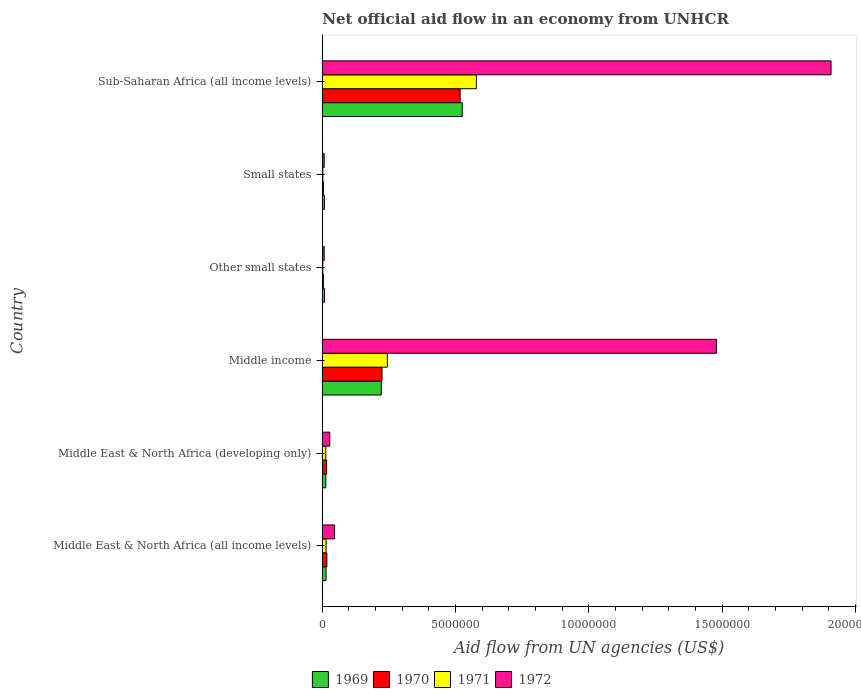How many groups of bars are there?
Provide a succinct answer. 6. Are the number of bars on each tick of the Y-axis equal?
Keep it short and to the point. Yes. How many bars are there on the 1st tick from the top?
Make the answer very short. 4. How many bars are there on the 4th tick from the bottom?
Your answer should be very brief. 4. What is the label of the 3rd group of bars from the top?
Offer a very short reply. Other small states. In how many cases, is the number of bars for a given country not equal to the number of legend labels?
Keep it short and to the point. 0. What is the net official aid flow in 1971 in Middle income?
Provide a succinct answer. 2.44e+06. Across all countries, what is the maximum net official aid flow in 1972?
Give a very brief answer. 1.91e+07. In which country was the net official aid flow in 1972 maximum?
Offer a very short reply. Sub-Saharan Africa (all income levels). In which country was the net official aid flow in 1972 minimum?
Make the answer very short. Other small states. What is the total net official aid flow in 1971 in the graph?
Your response must be concise. 8.53e+06. What is the difference between the net official aid flow in 1970 in Middle income and that in Sub-Saharan Africa (all income levels)?
Keep it short and to the point. -2.93e+06. What is the average net official aid flow in 1972 per country?
Ensure brevity in your answer.  5.79e+06. What is the ratio of the net official aid flow in 1972 in Small states to that in Sub-Saharan Africa (all income levels)?
Offer a terse response. 0. Is the net official aid flow in 1972 in Middle income less than that in Sub-Saharan Africa (all income levels)?
Ensure brevity in your answer.  Yes. What is the difference between the highest and the second highest net official aid flow in 1972?
Provide a short and direct response. 4.30e+06. What is the difference between the highest and the lowest net official aid flow in 1972?
Ensure brevity in your answer.  1.90e+07. In how many countries, is the net official aid flow in 1972 greater than the average net official aid flow in 1972 taken over all countries?
Your answer should be compact. 2. Is the sum of the net official aid flow in 1971 in Middle income and Small states greater than the maximum net official aid flow in 1969 across all countries?
Your response must be concise. No. Is it the case that in every country, the sum of the net official aid flow in 1971 and net official aid flow in 1970 is greater than the sum of net official aid flow in 1972 and net official aid flow in 1969?
Ensure brevity in your answer.  No. What does the 3rd bar from the top in Middle income represents?
Ensure brevity in your answer.  1970. What does the 2nd bar from the bottom in Other small states represents?
Provide a succinct answer. 1970. Are all the bars in the graph horizontal?
Offer a terse response. Yes. How many countries are there in the graph?
Make the answer very short. 6. What is the difference between two consecutive major ticks on the X-axis?
Keep it short and to the point. 5.00e+06. Where does the legend appear in the graph?
Your answer should be compact. Bottom center. How are the legend labels stacked?
Make the answer very short. Horizontal. What is the title of the graph?
Offer a terse response. Net official aid flow in an economy from UNHCR. Does "1996" appear as one of the legend labels in the graph?
Provide a succinct answer. No. What is the label or title of the X-axis?
Your answer should be very brief. Aid flow from UN agencies (US$). What is the Aid flow from UN agencies (US$) in 1970 in Middle East & North Africa (all income levels)?
Keep it short and to the point. 1.70e+05. What is the Aid flow from UN agencies (US$) of 1972 in Middle East & North Africa (all income levels)?
Provide a succinct answer. 4.60e+05. What is the Aid flow from UN agencies (US$) of 1970 in Middle East & North Africa (developing only)?
Your response must be concise. 1.60e+05. What is the Aid flow from UN agencies (US$) in 1971 in Middle East & North Africa (developing only)?
Your answer should be very brief. 1.30e+05. What is the Aid flow from UN agencies (US$) of 1969 in Middle income?
Give a very brief answer. 2.21e+06. What is the Aid flow from UN agencies (US$) in 1970 in Middle income?
Your response must be concise. 2.24e+06. What is the Aid flow from UN agencies (US$) of 1971 in Middle income?
Offer a very short reply. 2.44e+06. What is the Aid flow from UN agencies (US$) in 1972 in Middle income?
Your answer should be very brief. 1.48e+07. What is the Aid flow from UN agencies (US$) in 1969 in Other small states?
Provide a short and direct response. 8.00e+04. What is the Aid flow from UN agencies (US$) of 1970 in Other small states?
Offer a very short reply. 4.00e+04. What is the Aid flow from UN agencies (US$) in 1971 in Other small states?
Offer a terse response. 2.00e+04. What is the Aid flow from UN agencies (US$) in 1969 in Small states?
Give a very brief answer. 8.00e+04. What is the Aid flow from UN agencies (US$) of 1971 in Small states?
Offer a terse response. 2.00e+04. What is the Aid flow from UN agencies (US$) of 1969 in Sub-Saharan Africa (all income levels)?
Your answer should be compact. 5.25e+06. What is the Aid flow from UN agencies (US$) in 1970 in Sub-Saharan Africa (all income levels)?
Give a very brief answer. 5.17e+06. What is the Aid flow from UN agencies (US$) of 1971 in Sub-Saharan Africa (all income levels)?
Keep it short and to the point. 5.78e+06. What is the Aid flow from UN agencies (US$) in 1972 in Sub-Saharan Africa (all income levels)?
Make the answer very short. 1.91e+07. Across all countries, what is the maximum Aid flow from UN agencies (US$) of 1969?
Make the answer very short. 5.25e+06. Across all countries, what is the maximum Aid flow from UN agencies (US$) of 1970?
Your answer should be very brief. 5.17e+06. Across all countries, what is the maximum Aid flow from UN agencies (US$) of 1971?
Provide a short and direct response. 5.78e+06. Across all countries, what is the maximum Aid flow from UN agencies (US$) of 1972?
Your answer should be compact. 1.91e+07. Across all countries, what is the minimum Aid flow from UN agencies (US$) in 1971?
Your answer should be very brief. 2.00e+04. What is the total Aid flow from UN agencies (US$) in 1969 in the graph?
Your response must be concise. 7.89e+06. What is the total Aid flow from UN agencies (US$) of 1970 in the graph?
Provide a short and direct response. 7.82e+06. What is the total Aid flow from UN agencies (US$) in 1971 in the graph?
Offer a very short reply. 8.53e+06. What is the total Aid flow from UN agencies (US$) of 1972 in the graph?
Your response must be concise. 3.48e+07. What is the difference between the Aid flow from UN agencies (US$) of 1971 in Middle East & North Africa (all income levels) and that in Middle East & North Africa (developing only)?
Provide a short and direct response. 10000. What is the difference between the Aid flow from UN agencies (US$) of 1972 in Middle East & North Africa (all income levels) and that in Middle East & North Africa (developing only)?
Offer a terse response. 1.80e+05. What is the difference between the Aid flow from UN agencies (US$) in 1969 in Middle East & North Africa (all income levels) and that in Middle income?
Keep it short and to the point. -2.07e+06. What is the difference between the Aid flow from UN agencies (US$) in 1970 in Middle East & North Africa (all income levels) and that in Middle income?
Keep it short and to the point. -2.07e+06. What is the difference between the Aid flow from UN agencies (US$) in 1971 in Middle East & North Africa (all income levels) and that in Middle income?
Your answer should be compact. -2.30e+06. What is the difference between the Aid flow from UN agencies (US$) of 1972 in Middle East & North Africa (all income levels) and that in Middle income?
Make the answer very short. -1.43e+07. What is the difference between the Aid flow from UN agencies (US$) of 1969 in Middle East & North Africa (all income levels) and that in Small states?
Make the answer very short. 6.00e+04. What is the difference between the Aid flow from UN agencies (US$) of 1970 in Middle East & North Africa (all income levels) and that in Small states?
Make the answer very short. 1.30e+05. What is the difference between the Aid flow from UN agencies (US$) in 1971 in Middle East & North Africa (all income levels) and that in Small states?
Your response must be concise. 1.20e+05. What is the difference between the Aid flow from UN agencies (US$) in 1972 in Middle East & North Africa (all income levels) and that in Small states?
Provide a succinct answer. 3.90e+05. What is the difference between the Aid flow from UN agencies (US$) of 1969 in Middle East & North Africa (all income levels) and that in Sub-Saharan Africa (all income levels)?
Your response must be concise. -5.11e+06. What is the difference between the Aid flow from UN agencies (US$) in 1970 in Middle East & North Africa (all income levels) and that in Sub-Saharan Africa (all income levels)?
Your answer should be very brief. -5.00e+06. What is the difference between the Aid flow from UN agencies (US$) of 1971 in Middle East & North Africa (all income levels) and that in Sub-Saharan Africa (all income levels)?
Offer a terse response. -5.64e+06. What is the difference between the Aid flow from UN agencies (US$) in 1972 in Middle East & North Africa (all income levels) and that in Sub-Saharan Africa (all income levels)?
Keep it short and to the point. -1.86e+07. What is the difference between the Aid flow from UN agencies (US$) in 1969 in Middle East & North Africa (developing only) and that in Middle income?
Provide a short and direct response. -2.08e+06. What is the difference between the Aid flow from UN agencies (US$) in 1970 in Middle East & North Africa (developing only) and that in Middle income?
Ensure brevity in your answer.  -2.08e+06. What is the difference between the Aid flow from UN agencies (US$) of 1971 in Middle East & North Africa (developing only) and that in Middle income?
Make the answer very short. -2.31e+06. What is the difference between the Aid flow from UN agencies (US$) of 1972 in Middle East & North Africa (developing only) and that in Middle income?
Ensure brevity in your answer.  -1.45e+07. What is the difference between the Aid flow from UN agencies (US$) in 1972 in Middle East & North Africa (developing only) and that in Other small states?
Your response must be concise. 2.10e+05. What is the difference between the Aid flow from UN agencies (US$) of 1969 in Middle East & North Africa (developing only) and that in Small states?
Offer a terse response. 5.00e+04. What is the difference between the Aid flow from UN agencies (US$) of 1971 in Middle East & North Africa (developing only) and that in Small states?
Offer a terse response. 1.10e+05. What is the difference between the Aid flow from UN agencies (US$) of 1969 in Middle East & North Africa (developing only) and that in Sub-Saharan Africa (all income levels)?
Keep it short and to the point. -5.12e+06. What is the difference between the Aid flow from UN agencies (US$) in 1970 in Middle East & North Africa (developing only) and that in Sub-Saharan Africa (all income levels)?
Give a very brief answer. -5.01e+06. What is the difference between the Aid flow from UN agencies (US$) of 1971 in Middle East & North Africa (developing only) and that in Sub-Saharan Africa (all income levels)?
Offer a terse response. -5.65e+06. What is the difference between the Aid flow from UN agencies (US$) in 1972 in Middle East & North Africa (developing only) and that in Sub-Saharan Africa (all income levels)?
Keep it short and to the point. -1.88e+07. What is the difference between the Aid flow from UN agencies (US$) in 1969 in Middle income and that in Other small states?
Keep it short and to the point. 2.13e+06. What is the difference between the Aid flow from UN agencies (US$) in 1970 in Middle income and that in Other small states?
Offer a very short reply. 2.20e+06. What is the difference between the Aid flow from UN agencies (US$) of 1971 in Middle income and that in Other small states?
Offer a terse response. 2.42e+06. What is the difference between the Aid flow from UN agencies (US$) of 1972 in Middle income and that in Other small states?
Provide a short and direct response. 1.47e+07. What is the difference between the Aid flow from UN agencies (US$) of 1969 in Middle income and that in Small states?
Provide a short and direct response. 2.13e+06. What is the difference between the Aid flow from UN agencies (US$) of 1970 in Middle income and that in Small states?
Provide a succinct answer. 2.20e+06. What is the difference between the Aid flow from UN agencies (US$) in 1971 in Middle income and that in Small states?
Ensure brevity in your answer.  2.42e+06. What is the difference between the Aid flow from UN agencies (US$) of 1972 in Middle income and that in Small states?
Your response must be concise. 1.47e+07. What is the difference between the Aid flow from UN agencies (US$) of 1969 in Middle income and that in Sub-Saharan Africa (all income levels)?
Make the answer very short. -3.04e+06. What is the difference between the Aid flow from UN agencies (US$) in 1970 in Middle income and that in Sub-Saharan Africa (all income levels)?
Ensure brevity in your answer.  -2.93e+06. What is the difference between the Aid flow from UN agencies (US$) of 1971 in Middle income and that in Sub-Saharan Africa (all income levels)?
Provide a succinct answer. -3.34e+06. What is the difference between the Aid flow from UN agencies (US$) of 1972 in Middle income and that in Sub-Saharan Africa (all income levels)?
Provide a succinct answer. -4.30e+06. What is the difference between the Aid flow from UN agencies (US$) of 1969 in Other small states and that in Small states?
Your response must be concise. 0. What is the difference between the Aid flow from UN agencies (US$) in 1971 in Other small states and that in Small states?
Provide a succinct answer. 0. What is the difference between the Aid flow from UN agencies (US$) of 1969 in Other small states and that in Sub-Saharan Africa (all income levels)?
Give a very brief answer. -5.17e+06. What is the difference between the Aid flow from UN agencies (US$) in 1970 in Other small states and that in Sub-Saharan Africa (all income levels)?
Offer a very short reply. -5.13e+06. What is the difference between the Aid flow from UN agencies (US$) in 1971 in Other small states and that in Sub-Saharan Africa (all income levels)?
Provide a succinct answer. -5.76e+06. What is the difference between the Aid flow from UN agencies (US$) of 1972 in Other small states and that in Sub-Saharan Africa (all income levels)?
Keep it short and to the point. -1.90e+07. What is the difference between the Aid flow from UN agencies (US$) in 1969 in Small states and that in Sub-Saharan Africa (all income levels)?
Ensure brevity in your answer.  -5.17e+06. What is the difference between the Aid flow from UN agencies (US$) of 1970 in Small states and that in Sub-Saharan Africa (all income levels)?
Give a very brief answer. -5.13e+06. What is the difference between the Aid flow from UN agencies (US$) of 1971 in Small states and that in Sub-Saharan Africa (all income levels)?
Give a very brief answer. -5.76e+06. What is the difference between the Aid flow from UN agencies (US$) of 1972 in Small states and that in Sub-Saharan Africa (all income levels)?
Offer a terse response. -1.90e+07. What is the difference between the Aid flow from UN agencies (US$) of 1969 in Middle East & North Africa (all income levels) and the Aid flow from UN agencies (US$) of 1971 in Middle East & North Africa (developing only)?
Offer a very short reply. 10000. What is the difference between the Aid flow from UN agencies (US$) in 1969 in Middle East & North Africa (all income levels) and the Aid flow from UN agencies (US$) in 1972 in Middle East & North Africa (developing only)?
Your response must be concise. -1.40e+05. What is the difference between the Aid flow from UN agencies (US$) in 1971 in Middle East & North Africa (all income levels) and the Aid flow from UN agencies (US$) in 1972 in Middle East & North Africa (developing only)?
Ensure brevity in your answer.  -1.40e+05. What is the difference between the Aid flow from UN agencies (US$) in 1969 in Middle East & North Africa (all income levels) and the Aid flow from UN agencies (US$) in 1970 in Middle income?
Keep it short and to the point. -2.10e+06. What is the difference between the Aid flow from UN agencies (US$) in 1969 in Middle East & North Africa (all income levels) and the Aid flow from UN agencies (US$) in 1971 in Middle income?
Your response must be concise. -2.30e+06. What is the difference between the Aid flow from UN agencies (US$) in 1969 in Middle East & North Africa (all income levels) and the Aid flow from UN agencies (US$) in 1972 in Middle income?
Offer a terse response. -1.46e+07. What is the difference between the Aid flow from UN agencies (US$) of 1970 in Middle East & North Africa (all income levels) and the Aid flow from UN agencies (US$) of 1971 in Middle income?
Your answer should be very brief. -2.27e+06. What is the difference between the Aid flow from UN agencies (US$) in 1970 in Middle East & North Africa (all income levels) and the Aid flow from UN agencies (US$) in 1972 in Middle income?
Offer a very short reply. -1.46e+07. What is the difference between the Aid flow from UN agencies (US$) of 1971 in Middle East & North Africa (all income levels) and the Aid flow from UN agencies (US$) of 1972 in Middle income?
Your answer should be very brief. -1.46e+07. What is the difference between the Aid flow from UN agencies (US$) in 1969 in Middle East & North Africa (all income levels) and the Aid flow from UN agencies (US$) in 1970 in Other small states?
Provide a short and direct response. 1.00e+05. What is the difference between the Aid flow from UN agencies (US$) in 1970 in Middle East & North Africa (all income levels) and the Aid flow from UN agencies (US$) in 1971 in Other small states?
Offer a terse response. 1.50e+05. What is the difference between the Aid flow from UN agencies (US$) in 1971 in Middle East & North Africa (all income levels) and the Aid flow from UN agencies (US$) in 1972 in Other small states?
Ensure brevity in your answer.  7.00e+04. What is the difference between the Aid flow from UN agencies (US$) in 1969 in Middle East & North Africa (all income levels) and the Aid flow from UN agencies (US$) in 1972 in Small states?
Your answer should be compact. 7.00e+04. What is the difference between the Aid flow from UN agencies (US$) in 1970 in Middle East & North Africa (all income levels) and the Aid flow from UN agencies (US$) in 1971 in Small states?
Your answer should be very brief. 1.50e+05. What is the difference between the Aid flow from UN agencies (US$) of 1970 in Middle East & North Africa (all income levels) and the Aid flow from UN agencies (US$) of 1972 in Small states?
Offer a very short reply. 1.00e+05. What is the difference between the Aid flow from UN agencies (US$) in 1971 in Middle East & North Africa (all income levels) and the Aid flow from UN agencies (US$) in 1972 in Small states?
Offer a very short reply. 7.00e+04. What is the difference between the Aid flow from UN agencies (US$) of 1969 in Middle East & North Africa (all income levels) and the Aid flow from UN agencies (US$) of 1970 in Sub-Saharan Africa (all income levels)?
Your answer should be very brief. -5.03e+06. What is the difference between the Aid flow from UN agencies (US$) in 1969 in Middle East & North Africa (all income levels) and the Aid flow from UN agencies (US$) in 1971 in Sub-Saharan Africa (all income levels)?
Give a very brief answer. -5.64e+06. What is the difference between the Aid flow from UN agencies (US$) in 1969 in Middle East & North Africa (all income levels) and the Aid flow from UN agencies (US$) in 1972 in Sub-Saharan Africa (all income levels)?
Give a very brief answer. -1.90e+07. What is the difference between the Aid flow from UN agencies (US$) in 1970 in Middle East & North Africa (all income levels) and the Aid flow from UN agencies (US$) in 1971 in Sub-Saharan Africa (all income levels)?
Keep it short and to the point. -5.61e+06. What is the difference between the Aid flow from UN agencies (US$) in 1970 in Middle East & North Africa (all income levels) and the Aid flow from UN agencies (US$) in 1972 in Sub-Saharan Africa (all income levels)?
Give a very brief answer. -1.89e+07. What is the difference between the Aid flow from UN agencies (US$) of 1971 in Middle East & North Africa (all income levels) and the Aid flow from UN agencies (US$) of 1972 in Sub-Saharan Africa (all income levels)?
Your answer should be compact. -1.90e+07. What is the difference between the Aid flow from UN agencies (US$) in 1969 in Middle East & North Africa (developing only) and the Aid flow from UN agencies (US$) in 1970 in Middle income?
Your response must be concise. -2.11e+06. What is the difference between the Aid flow from UN agencies (US$) in 1969 in Middle East & North Africa (developing only) and the Aid flow from UN agencies (US$) in 1971 in Middle income?
Your answer should be compact. -2.31e+06. What is the difference between the Aid flow from UN agencies (US$) of 1969 in Middle East & North Africa (developing only) and the Aid flow from UN agencies (US$) of 1972 in Middle income?
Offer a very short reply. -1.47e+07. What is the difference between the Aid flow from UN agencies (US$) in 1970 in Middle East & North Africa (developing only) and the Aid flow from UN agencies (US$) in 1971 in Middle income?
Provide a succinct answer. -2.28e+06. What is the difference between the Aid flow from UN agencies (US$) in 1970 in Middle East & North Africa (developing only) and the Aid flow from UN agencies (US$) in 1972 in Middle income?
Offer a very short reply. -1.46e+07. What is the difference between the Aid flow from UN agencies (US$) in 1971 in Middle East & North Africa (developing only) and the Aid flow from UN agencies (US$) in 1972 in Middle income?
Keep it short and to the point. -1.47e+07. What is the difference between the Aid flow from UN agencies (US$) in 1969 in Middle East & North Africa (developing only) and the Aid flow from UN agencies (US$) in 1970 in Other small states?
Your response must be concise. 9.00e+04. What is the difference between the Aid flow from UN agencies (US$) in 1969 in Middle East & North Africa (developing only) and the Aid flow from UN agencies (US$) in 1971 in Other small states?
Offer a terse response. 1.10e+05. What is the difference between the Aid flow from UN agencies (US$) of 1969 in Middle East & North Africa (developing only) and the Aid flow from UN agencies (US$) of 1972 in Other small states?
Provide a short and direct response. 6.00e+04. What is the difference between the Aid flow from UN agencies (US$) of 1970 in Middle East & North Africa (developing only) and the Aid flow from UN agencies (US$) of 1971 in Other small states?
Provide a succinct answer. 1.40e+05. What is the difference between the Aid flow from UN agencies (US$) of 1970 in Middle East & North Africa (developing only) and the Aid flow from UN agencies (US$) of 1972 in Other small states?
Ensure brevity in your answer.  9.00e+04. What is the difference between the Aid flow from UN agencies (US$) in 1969 in Middle East & North Africa (developing only) and the Aid flow from UN agencies (US$) in 1970 in Small states?
Give a very brief answer. 9.00e+04. What is the difference between the Aid flow from UN agencies (US$) of 1969 in Middle East & North Africa (developing only) and the Aid flow from UN agencies (US$) of 1971 in Small states?
Provide a succinct answer. 1.10e+05. What is the difference between the Aid flow from UN agencies (US$) in 1970 in Middle East & North Africa (developing only) and the Aid flow from UN agencies (US$) in 1972 in Small states?
Your answer should be compact. 9.00e+04. What is the difference between the Aid flow from UN agencies (US$) of 1969 in Middle East & North Africa (developing only) and the Aid flow from UN agencies (US$) of 1970 in Sub-Saharan Africa (all income levels)?
Offer a very short reply. -5.04e+06. What is the difference between the Aid flow from UN agencies (US$) of 1969 in Middle East & North Africa (developing only) and the Aid flow from UN agencies (US$) of 1971 in Sub-Saharan Africa (all income levels)?
Your response must be concise. -5.65e+06. What is the difference between the Aid flow from UN agencies (US$) in 1969 in Middle East & North Africa (developing only) and the Aid flow from UN agencies (US$) in 1972 in Sub-Saharan Africa (all income levels)?
Make the answer very short. -1.90e+07. What is the difference between the Aid flow from UN agencies (US$) of 1970 in Middle East & North Africa (developing only) and the Aid flow from UN agencies (US$) of 1971 in Sub-Saharan Africa (all income levels)?
Provide a short and direct response. -5.62e+06. What is the difference between the Aid flow from UN agencies (US$) in 1970 in Middle East & North Africa (developing only) and the Aid flow from UN agencies (US$) in 1972 in Sub-Saharan Africa (all income levels)?
Make the answer very short. -1.89e+07. What is the difference between the Aid flow from UN agencies (US$) of 1971 in Middle East & North Africa (developing only) and the Aid flow from UN agencies (US$) of 1972 in Sub-Saharan Africa (all income levels)?
Provide a succinct answer. -1.90e+07. What is the difference between the Aid flow from UN agencies (US$) in 1969 in Middle income and the Aid flow from UN agencies (US$) in 1970 in Other small states?
Give a very brief answer. 2.17e+06. What is the difference between the Aid flow from UN agencies (US$) in 1969 in Middle income and the Aid flow from UN agencies (US$) in 1971 in Other small states?
Ensure brevity in your answer.  2.19e+06. What is the difference between the Aid flow from UN agencies (US$) of 1969 in Middle income and the Aid flow from UN agencies (US$) of 1972 in Other small states?
Ensure brevity in your answer.  2.14e+06. What is the difference between the Aid flow from UN agencies (US$) in 1970 in Middle income and the Aid flow from UN agencies (US$) in 1971 in Other small states?
Your answer should be very brief. 2.22e+06. What is the difference between the Aid flow from UN agencies (US$) in 1970 in Middle income and the Aid flow from UN agencies (US$) in 1972 in Other small states?
Make the answer very short. 2.17e+06. What is the difference between the Aid flow from UN agencies (US$) in 1971 in Middle income and the Aid flow from UN agencies (US$) in 1972 in Other small states?
Make the answer very short. 2.37e+06. What is the difference between the Aid flow from UN agencies (US$) in 1969 in Middle income and the Aid flow from UN agencies (US$) in 1970 in Small states?
Offer a terse response. 2.17e+06. What is the difference between the Aid flow from UN agencies (US$) in 1969 in Middle income and the Aid flow from UN agencies (US$) in 1971 in Small states?
Ensure brevity in your answer.  2.19e+06. What is the difference between the Aid flow from UN agencies (US$) in 1969 in Middle income and the Aid flow from UN agencies (US$) in 1972 in Small states?
Provide a succinct answer. 2.14e+06. What is the difference between the Aid flow from UN agencies (US$) of 1970 in Middle income and the Aid flow from UN agencies (US$) of 1971 in Small states?
Make the answer very short. 2.22e+06. What is the difference between the Aid flow from UN agencies (US$) of 1970 in Middle income and the Aid flow from UN agencies (US$) of 1972 in Small states?
Provide a succinct answer. 2.17e+06. What is the difference between the Aid flow from UN agencies (US$) in 1971 in Middle income and the Aid flow from UN agencies (US$) in 1972 in Small states?
Give a very brief answer. 2.37e+06. What is the difference between the Aid flow from UN agencies (US$) in 1969 in Middle income and the Aid flow from UN agencies (US$) in 1970 in Sub-Saharan Africa (all income levels)?
Your answer should be very brief. -2.96e+06. What is the difference between the Aid flow from UN agencies (US$) of 1969 in Middle income and the Aid flow from UN agencies (US$) of 1971 in Sub-Saharan Africa (all income levels)?
Make the answer very short. -3.57e+06. What is the difference between the Aid flow from UN agencies (US$) of 1969 in Middle income and the Aid flow from UN agencies (US$) of 1972 in Sub-Saharan Africa (all income levels)?
Your answer should be compact. -1.69e+07. What is the difference between the Aid flow from UN agencies (US$) of 1970 in Middle income and the Aid flow from UN agencies (US$) of 1971 in Sub-Saharan Africa (all income levels)?
Your answer should be compact. -3.54e+06. What is the difference between the Aid flow from UN agencies (US$) of 1970 in Middle income and the Aid flow from UN agencies (US$) of 1972 in Sub-Saharan Africa (all income levels)?
Provide a short and direct response. -1.68e+07. What is the difference between the Aid flow from UN agencies (US$) of 1971 in Middle income and the Aid flow from UN agencies (US$) of 1972 in Sub-Saharan Africa (all income levels)?
Give a very brief answer. -1.66e+07. What is the difference between the Aid flow from UN agencies (US$) of 1969 in Other small states and the Aid flow from UN agencies (US$) of 1970 in Small states?
Offer a terse response. 4.00e+04. What is the difference between the Aid flow from UN agencies (US$) of 1969 in Other small states and the Aid flow from UN agencies (US$) of 1971 in Small states?
Give a very brief answer. 6.00e+04. What is the difference between the Aid flow from UN agencies (US$) of 1969 in Other small states and the Aid flow from UN agencies (US$) of 1972 in Small states?
Your answer should be very brief. 10000. What is the difference between the Aid flow from UN agencies (US$) of 1970 in Other small states and the Aid flow from UN agencies (US$) of 1972 in Small states?
Offer a terse response. -3.00e+04. What is the difference between the Aid flow from UN agencies (US$) of 1971 in Other small states and the Aid flow from UN agencies (US$) of 1972 in Small states?
Provide a succinct answer. -5.00e+04. What is the difference between the Aid flow from UN agencies (US$) in 1969 in Other small states and the Aid flow from UN agencies (US$) in 1970 in Sub-Saharan Africa (all income levels)?
Offer a very short reply. -5.09e+06. What is the difference between the Aid flow from UN agencies (US$) of 1969 in Other small states and the Aid flow from UN agencies (US$) of 1971 in Sub-Saharan Africa (all income levels)?
Make the answer very short. -5.70e+06. What is the difference between the Aid flow from UN agencies (US$) of 1969 in Other small states and the Aid flow from UN agencies (US$) of 1972 in Sub-Saharan Africa (all income levels)?
Keep it short and to the point. -1.90e+07. What is the difference between the Aid flow from UN agencies (US$) in 1970 in Other small states and the Aid flow from UN agencies (US$) in 1971 in Sub-Saharan Africa (all income levels)?
Offer a very short reply. -5.74e+06. What is the difference between the Aid flow from UN agencies (US$) of 1970 in Other small states and the Aid flow from UN agencies (US$) of 1972 in Sub-Saharan Africa (all income levels)?
Your response must be concise. -1.90e+07. What is the difference between the Aid flow from UN agencies (US$) in 1971 in Other small states and the Aid flow from UN agencies (US$) in 1972 in Sub-Saharan Africa (all income levels)?
Your answer should be very brief. -1.91e+07. What is the difference between the Aid flow from UN agencies (US$) in 1969 in Small states and the Aid flow from UN agencies (US$) in 1970 in Sub-Saharan Africa (all income levels)?
Ensure brevity in your answer.  -5.09e+06. What is the difference between the Aid flow from UN agencies (US$) of 1969 in Small states and the Aid flow from UN agencies (US$) of 1971 in Sub-Saharan Africa (all income levels)?
Provide a short and direct response. -5.70e+06. What is the difference between the Aid flow from UN agencies (US$) of 1969 in Small states and the Aid flow from UN agencies (US$) of 1972 in Sub-Saharan Africa (all income levels)?
Make the answer very short. -1.90e+07. What is the difference between the Aid flow from UN agencies (US$) of 1970 in Small states and the Aid flow from UN agencies (US$) of 1971 in Sub-Saharan Africa (all income levels)?
Give a very brief answer. -5.74e+06. What is the difference between the Aid flow from UN agencies (US$) in 1970 in Small states and the Aid flow from UN agencies (US$) in 1972 in Sub-Saharan Africa (all income levels)?
Keep it short and to the point. -1.90e+07. What is the difference between the Aid flow from UN agencies (US$) in 1971 in Small states and the Aid flow from UN agencies (US$) in 1972 in Sub-Saharan Africa (all income levels)?
Make the answer very short. -1.91e+07. What is the average Aid flow from UN agencies (US$) in 1969 per country?
Offer a terse response. 1.32e+06. What is the average Aid flow from UN agencies (US$) in 1970 per country?
Keep it short and to the point. 1.30e+06. What is the average Aid flow from UN agencies (US$) of 1971 per country?
Your answer should be compact. 1.42e+06. What is the average Aid flow from UN agencies (US$) of 1972 per country?
Ensure brevity in your answer.  5.79e+06. What is the difference between the Aid flow from UN agencies (US$) in 1969 and Aid flow from UN agencies (US$) in 1970 in Middle East & North Africa (all income levels)?
Your answer should be very brief. -3.00e+04. What is the difference between the Aid flow from UN agencies (US$) of 1969 and Aid flow from UN agencies (US$) of 1972 in Middle East & North Africa (all income levels)?
Provide a short and direct response. -3.20e+05. What is the difference between the Aid flow from UN agencies (US$) of 1970 and Aid flow from UN agencies (US$) of 1971 in Middle East & North Africa (all income levels)?
Offer a terse response. 3.00e+04. What is the difference between the Aid flow from UN agencies (US$) of 1971 and Aid flow from UN agencies (US$) of 1972 in Middle East & North Africa (all income levels)?
Offer a terse response. -3.20e+05. What is the difference between the Aid flow from UN agencies (US$) of 1969 and Aid flow from UN agencies (US$) of 1970 in Middle East & North Africa (developing only)?
Offer a very short reply. -3.00e+04. What is the difference between the Aid flow from UN agencies (US$) of 1969 and Aid flow from UN agencies (US$) of 1971 in Middle East & North Africa (developing only)?
Offer a very short reply. 0. What is the difference between the Aid flow from UN agencies (US$) of 1969 and Aid flow from UN agencies (US$) of 1972 in Middle East & North Africa (developing only)?
Give a very brief answer. -1.50e+05. What is the difference between the Aid flow from UN agencies (US$) of 1970 and Aid flow from UN agencies (US$) of 1972 in Middle East & North Africa (developing only)?
Make the answer very short. -1.20e+05. What is the difference between the Aid flow from UN agencies (US$) of 1971 and Aid flow from UN agencies (US$) of 1972 in Middle East & North Africa (developing only)?
Give a very brief answer. -1.50e+05. What is the difference between the Aid flow from UN agencies (US$) in 1969 and Aid flow from UN agencies (US$) in 1970 in Middle income?
Keep it short and to the point. -3.00e+04. What is the difference between the Aid flow from UN agencies (US$) in 1969 and Aid flow from UN agencies (US$) in 1972 in Middle income?
Keep it short and to the point. -1.26e+07. What is the difference between the Aid flow from UN agencies (US$) in 1970 and Aid flow from UN agencies (US$) in 1971 in Middle income?
Your answer should be very brief. -2.00e+05. What is the difference between the Aid flow from UN agencies (US$) of 1970 and Aid flow from UN agencies (US$) of 1972 in Middle income?
Provide a short and direct response. -1.26e+07. What is the difference between the Aid flow from UN agencies (US$) in 1971 and Aid flow from UN agencies (US$) in 1972 in Middle income?
Offer a terse response. -1.24e+07. What is the difference between the Aid flow from UN agencies (US$) in 1969 and Aid flow from UN agencies (US$) in 1971 in Other small states?
Your answer should be compact. 6.00e+04. What is the difference between the Aid flow from UN agencies (US$) of 1969 and Aid flow from UN agencies (US$) of 1972 in Other small states?
Your answer should be very brief. 10000. What is the difference between the Aid flow from UN agencies (US$) of 1969 and Aid flow from UN agencies (US$) of 1972 in Small states?
Your answer should be very brief. 10000. What is the difference between the Aid flow from UN agencies (US$) in 1970 and Aid flow from UN agencies (US$) in 1972 in Small states?
Your answer should be compact. -3.00e+04. What is the difference between the Aid flow from UN agencies (US$) of 1971 and Aid flow from UN agencies (US$) of 1972 in Small states?
Make the answer very short. -5.00e+04. What is the difference between the Aid flow from UN agencies (US$) in 1969 and Aid flow from UN agencies (US$) in 1970 in Sub-Saharan Africa (all income levels)?
Offer a terse response. 8.00e+04. What is the difference between the Aid flow from UN agencies (US$) in 1969 and Aid flow from UN agencies (US$) in 1971 in Sub-Saharan Africa (all income levels)?
Offer a very short reply. -5.30e+05. What is the difference between the Aid flow from UN agencies (US$) in 1969 and Aid flow from UN agencies (US$) in 1972 in Sub-Saharan Africa (all income levels)?
Your answer should be very brief. -1.38e+07. What is the difference between the Aid flow from UN agencies (US$) of 1970 and Aid flow from UN agencies (US$) of 1971 in Sub-Saharan Africa (all income levels)?
Your answer should be very brief. -6.10e+05. What is the difference between the Aid flow from UN agencies (US$) in 1970 and Aid flow from UN agencies (US$) in 1972 in Sub-Saharan Africa (all income levels)?
Provide a short and direct response. -1.39e+07. What is the difference between the Aid flow from UN agencies (US$) of 1971 and Aid flow from UN agencies (US$) of 1972 in Sub-Saharan Africa (all income levels)?
Your answer should be very brief. -1.33e+07. What is the ratio of the Aid flow from UN agencies (US$) of 1969 in Middle East & North Africa (all income levels) to that in Middle East & North Africa (developing only)?
Offer a terse response. 1.08. What is the ratio of the Aid flow from UN agencies (US$) in 1971 in Middle East & North Africa (all income levels) to that in Middle East & North Africa (developing only)?
Keep it short and to the point. 1.08. What is the ratio of the Aid flow from UN agencies (US$) of 1972 in Middle East & North Africa (all income levels) to that in Middle East & North Africa (developing only)?
Offer a terse response. 1.64. What is the ratio of the Aid flow from UN agencies (US$) of 1969 in Middle East & North Africa (all income levels) to that in Middle income?
Ensure brevity in your answer.  0.06. What is the ratio of the Aid flow from UN agencies (US$) in 1970 in Middle East & North Africa (all income levels) to that in Middle income?
Provide a short and direct response. 0.08. What is the ratio of the Aid flow from UN agencies (US$) in 1971 in Middle East & North Africa (all income levels) to that in Middle income?
Your answer should be compact. 0.06. What is the ratio of the Aid flow from UN agencies (US$) of 1972 in Middle East & North Africa (all income levels) to that in Middle income?
Provide a succinct answer. 0.03. What is the ratio of the Aid flow from UN agencies (US$) of 1970 in Middle East & North Africa (all income levels) to that in Other small states?
Provide a succinct answer. 4.25. What is the ratio of the Aid flow from UN agencies (US$) in 1971 in Middle East & North Africa (all income levels) to that in Other small states?
Keep it short and to the point. 7. What is the ratio of the Aid flow from UN agencies (US$) in 1972 in Middle East & North Africa (all income levels) to that in Other small states?
Keep it short and to the point. 6.57. What is the ratio of the Aid flow from UN agencies (US$) of 1970 in Middle East & North Africa (all income levels) to that in Small states?
Give a very brief answer. 4.25. What is the ratio of the Aid flow from UN agencies (US$) in 1972 in Middle East & North Africa (all income levels) to that in Small states?
Provide a short and direct response. 6.57. What is the ratio of the Aid flow from UN agencies (US$) of 1969 in Middle East & North Africa (all income levels) to that in Sub-Saharan Africa (all income levels)?
Ensure brevity in your answer.  0.03. What is the ratio of the Aid flow from UN agencies (US$) of 1970 in Middle East & North Africa (all income levels) to that in Sub-Saharan Africa (all income levels)?
Your response must be concise. 0.03. What is the ratio of the Aid flow from UN agencies (US$) of 1971 in Middle East & North Africa (all income levels) to that in Sub-Saharan Africa (all income levels)?
Make the answer very short. 0.02. What is the ratio of the Aid flow from UN agencies (US$) of 1972 in Middle East & North Africa (all income levels) to that in Sub-Saharan Africa (all income levels)?
Your answer should be very brief. 0.02. What is the ratio of the Aid flow from UN agencies (US$) of 1969 in Middle East & North Africa (developing only) to that in Middle income?
Offer a very short reply. 0.06. What is the ratio of the Aid flow from UN agencies (US$) in 1970 in Middle East & North Africa (developing only) to that in Middle income?
Keep it short and to the point. 0.07. What is the ratio of the Aid flow from UN agencies (US$) in 1971 in Middle East & North Africa (developing only) to that in Middle income?
Make the answer very short. 0.05. What is the ratio of the Aid flow from UN agencies (US$) of 1972 in Middle East & North Africa (developing only) to that in Middle income?
Make the answer very short. 0.02. What is the ratio of the Aid flow from UN agencies (US$) of 1969 in Middle East & North Africa (developing only) to that in Other small states?
Keep it short and to the point. 1.62. What is the ratio of the Aid flow from UN agencies (US$) in 1972 in Middle East & North Africa (developing only) to that in Other small states?
Your answer should be compact. 4. What is the ratio of the Aid flow from UN agencies (US$) of 1969 in Middle East & North Africa (developing only) to that in Small states?
Ensure brevity in your answer.  1.62. What is the ratio of the Aid flow from UN agencies (US$) of 1970 in Middle East & North Africa (developing only) to that in Small states?
Provide a succinct answer. 4. What is the ratio of the Aid flow from UN agencies (US$) in 1972 in Middle East & North Africa (developing only) to that in Small states?
Your answer should be compact. 4. What is the ratio of the Aid flow from UN agencies (US$) in 1969 in Middle East & North Africa (developing only) to that in Sub-Saharan Africa (all income levels)?
Provide a short and direct response. 0.02. What is the ratio of the Aid flow from UN agencies (US$) of 1970 in Middle East & North Africa (developing only) to that in Sub-Saharan Africa (all income levels)?
Provide a short and direct response. 0.03. What is the ratio of the Aid flow from UN agencies (US$) in 1971 in Middle East & North Africa (developing only) to that in Sub-Saharan Africa (all income levels)?
Your answer should be compact. 0.02. What is the ratio of the Aid flow from UN agencies (US$) of 1972 in Middle East & North Africa (developing only) to that in Sub-Saharan Africa (all income levels)?
Ensure brevity in your answer.  0.01. What is the ratio of the Aid flow from UN agencies (US$) of 1969 in Middle income to that in Other small states?
Keep it short and to the point. 27.62. What is the ratio of the Aid flow from UN agencies (US$) of 1970 in Middle income to that in Other small states?
Give a very brief answer. 56. What is the ratio of the Aid flow from UN agencies (US$) in 1971 in Middle income to that in Other small states?
Keep it short and to the point. 122. What is the ratio of the Aid flow from UN agencies (US$) of 1972 in Middle income to that in Other small states?
Provide a short and direct response. 211.29. What is the ratio of the Aid flow from UN agencies (US$) in 1969 in Middle income to that in Small states?
Your answer should be very brief. 27.62. What is the ratio of the Aid flow from UN agencies (US$) of 1970 in Middle income to that in Small states?
Your answer should be very brief. 56. What is the ratio of the Aid flow from UN agencies (US$) in 1971 in Middle income to that in Small states?
Provide a succinct answer. 122. What is the ratio of the Aid flow from UN agencies (US$) of 1972 in Middle income to that in Small states?
Provide a succinct answer. 211.29. What is the ratio of the Aid flow from UN agencies (US$) of 1969 in Middle income to that in Sub-Saharan Africa (all income levels)?
Your answer should be compact. 0.42. What is the ratio of the Aid flow from UN agencies (US$) of 1970 in Middle income to that in Sub-Saharan Africa (all income levels)?
Your answer should be compact. 0.43. What is the ratio of the Aid flow from UN agencies (US$) of 1971 in Middle income to that in Sub-Saharan Africa (all income levels)?
Your response must be concise. 0.42. What is the ratio of the Aid flow from UN agencies (US$) of 1972 in Middle income to that in Sub-Saharan Africa (all income levels)?
Your answer should be compact. 0.77. What is the ratio of the Aid flow from UN agencies (US$) of 1970 in Other small states to that in Small states?
Provide a short and direct response. 1. What is the ratio of the Aid flow from UN agencies (US$) of 1971 in Other small states to that in Small states?
Keep it short and to the point. 1. What is the ratio of the Aid flow from UN agencies (US$) in 1969 in Other small states to that in Sub-Saharan Africa (all income levels)?
Keep it short and to the point. 0.02. What is the ratio of the Aid flow from UN agencies (US$) of 1970 in Other small states to that in Sub-Saharan Africa (all income levels)?
Keep it short and to the point. 0.01. What is the ratio of the Aid flow from UN agencies (US$) of 1971 in Other small states to that in Sub-Saharan Africa (all income levels)?
Keep it short and to the point. 0. What is the ratio of the Aid flow from UN agencies (US$) in 1972 in Other small states to that in Sub-Saharan Africa (all income levels)?
Offer a very short reply. 0. What is the ratio of the Aid flow from UN agencies (US$) of 1969 in Small states to that in Sub-Saharan Africa (all income levels)?
Your answer should be compact. 0.02. What is the ratio of the Aid flow from UN agencies (US$) in 1970 in Small states to that in Sub-Saharan Africa (all income levels)?
Offer a very short reply. 0.01. What is the ratio of the Aid flow from UN agencies (US$) of 1971 in Small states to that in Sub-Saharan Africa (all income levels)?
Provide a succinct answer. 0. What is the ratio of the Aid flow from UN agencies (US$) in 1972 in Small states to that in Sub-Saharan Africa (all income levels)?
Your response must be concise. 0. What is the difference between the highest and the second highest Aid flow from UN agencies (US$) in 1969?
Keep it short and to the point. 3.04e+06. What is the difference between the highest and the second highest Aid flow from UN agencies (US$) of 1970?
Your answer should be compact. 2.93e+06. What is the difference between the highest and the second highest Aid flow from UN agencies (US$) in 1971?
Provide a succinct answer. 3.34e+06. What is the difference between the highest and the second highest Aid flow from UN agencies (US$) of 1972?
Your answer should be compact. 4.30e+06. What is the difference between the highest and the lowest Aid flow from UN agencies (US$) in 1969?
Provide a succinct answer. 5.17e+06. What is the difference between the highest and the lowest Aid flow from UN agencies (US$) in 1970?
Offer a very short reply. 5.13e+06. What is the difference between the highest and the lowest Aid flow from UN agencies (US$) in 1971?
Provide a succinct answer. 5.76e+06. What is the difference between the highest and the lowest Aid flow from UN agencies (US$) of 1972?
Make the answer very short. 1.90e+07. 